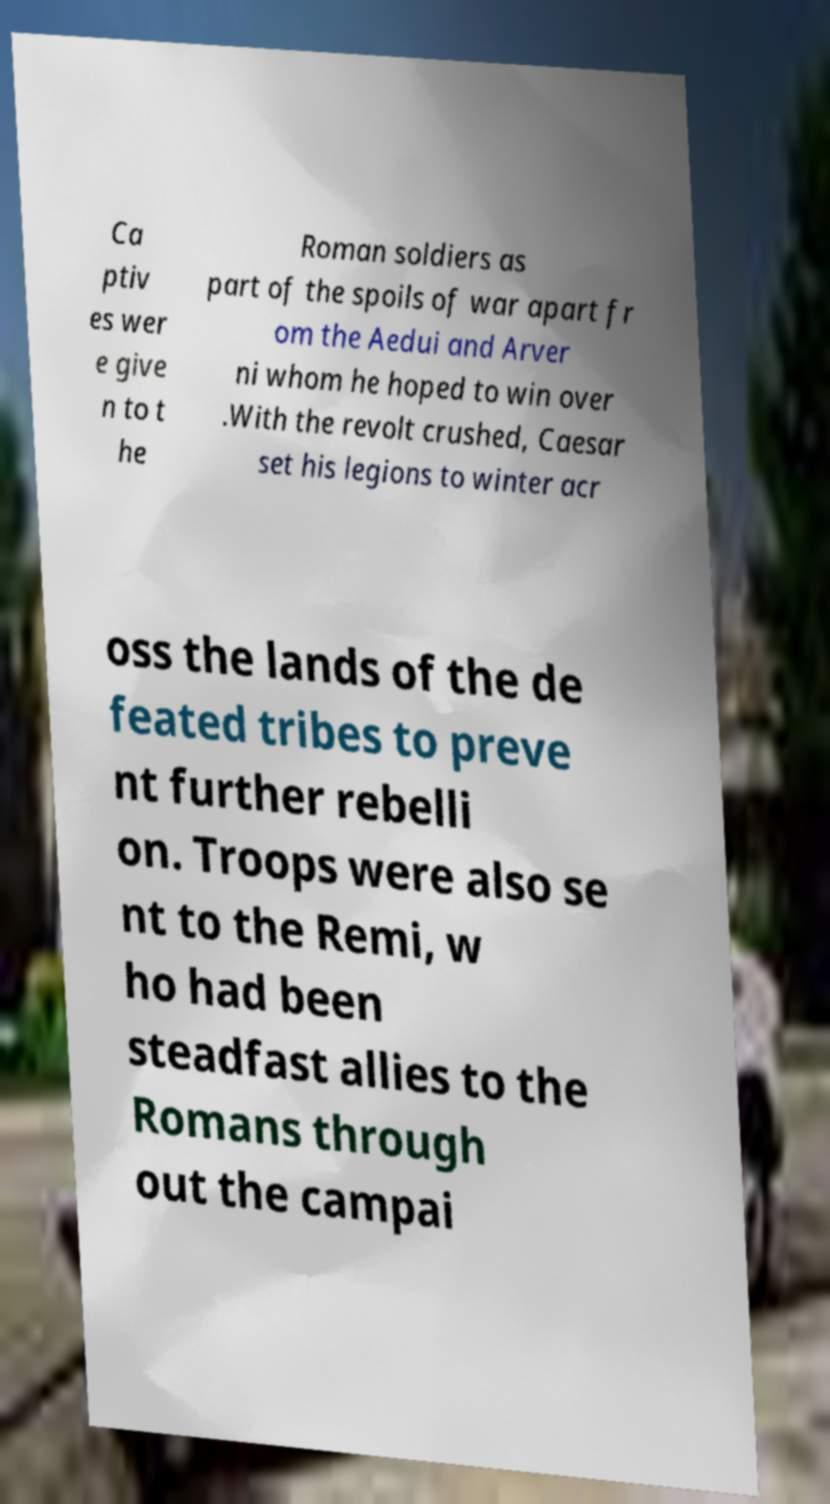Please read and relay the text visible in this image. What does it say? Ca ptiv es wer e give n to t he Roman soldiers as part of the spoils of war apart fr om the Aedui and Arver ni whom he hoped to win over .With the revolt crushed, Caesar set his legions to winter acr oss the lands of the de feated tribes to preve nt further rebelli on. Troops were also se nt to the Remi, w ho had been steadfast allies to the Romans through out the campai 